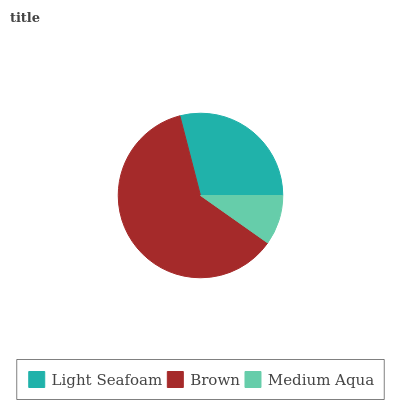Is Medium Aqua the minimum?
Answer yes or no. Yes. Is Brown the maximum?
Answer yes or no. Yes. Is Brown the minimum?
Answer yes or no. No. Is Medium Aqua the maximum?
Answer yes or no. No. Is Brown greater than Medium Aqua?
Answer yes or no. Yes. Is Medium Aqua less than Brown?
Answer yes or no. Yes. Is Medium Aqua greater than Brown?
Answer yes or no. No. Is Brown less than Medium Aqua?
Answer yes or no. No. Is Light Seafoam the high median?
Answer yes or no. Yes. Is Light Seafoam the low median?
Answer yes or no. Yes. Is Brown the high median?
Answer yes or no. No. Is Brown the low median?
Answer yes or no. No. 